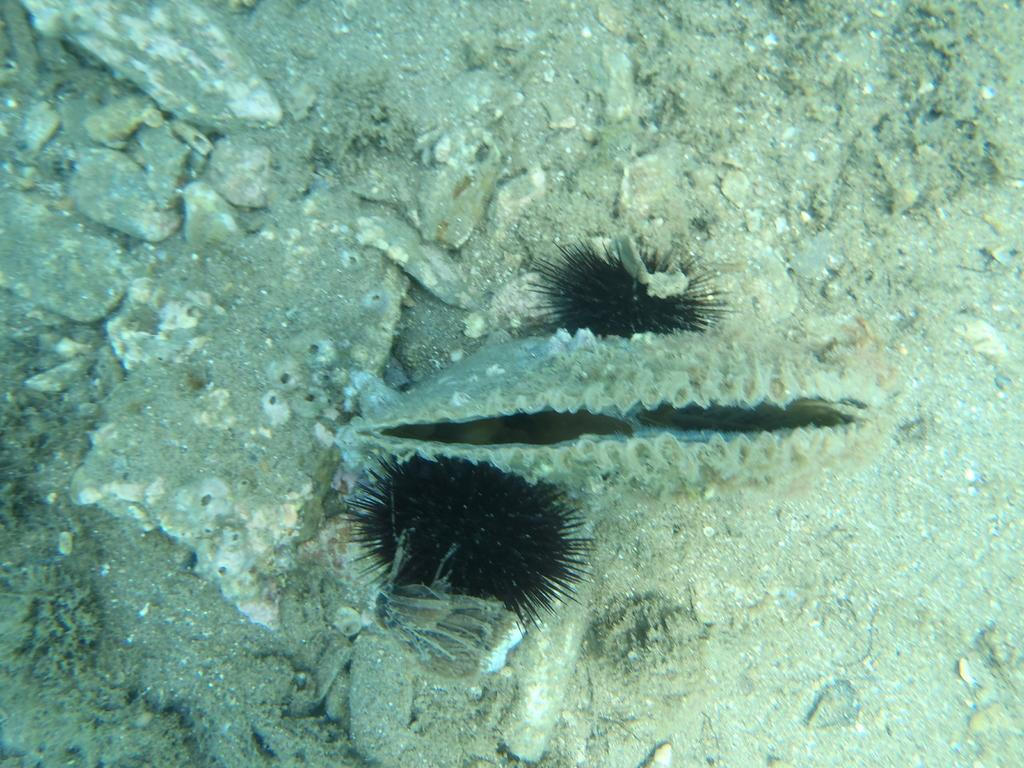Where was the picture taken? The picture was taken inside the water. What types of creatures can be seen in the image? There are water animals in the image. What can be seen on the ground in the image? Sand is visible in the image. What else is present on the ground in the image? Stones are present in the image. What thought is the watch having while playing chess in the image? There is no watch or chess game present in the image. 